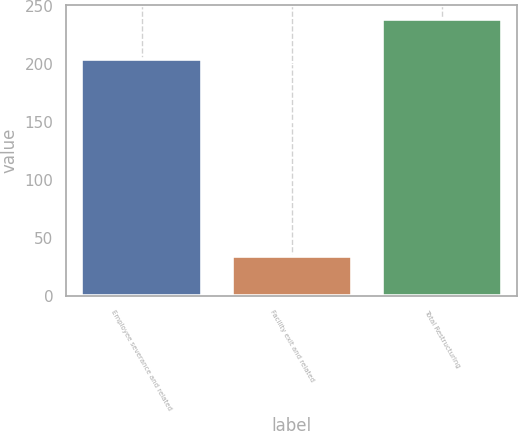<chart> <loc_0><loc_0><loc_500><loc_500><bar_chart><fcel>Employee severance and related<fcel>Facility exit and related<fcel>Total Restructuring<nl><fcel>203.9<fcel>34.6<fcel>238.5<nl></chart> 